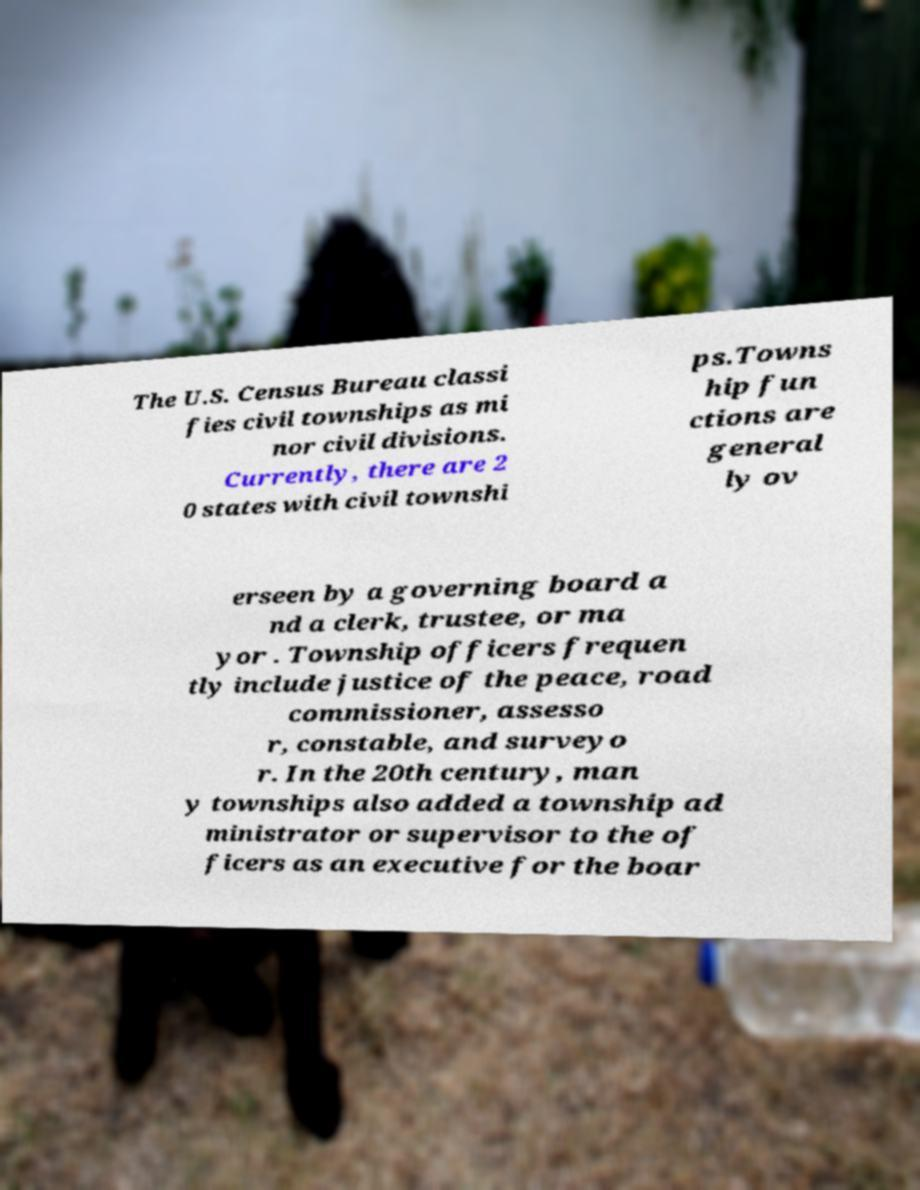What messages or text are displayed in this image? I need them in a readable, typed format. The U.S. Census Bureau classi fies civil townships as mi nor civil divisions. Currently, there are 2 0 states with civil townshi ps.Towns hip fun ctions are general ly ov erseen by a governing board a nd a clerk, trustee, or ma yor . Township officers frequen tly include justice of the peace, road commissioner, assesso r, constable, and surveyo r. In the 20th century, man y townships also added a township ad ministrator or supervisor to the of ficers as an executive for the boar 